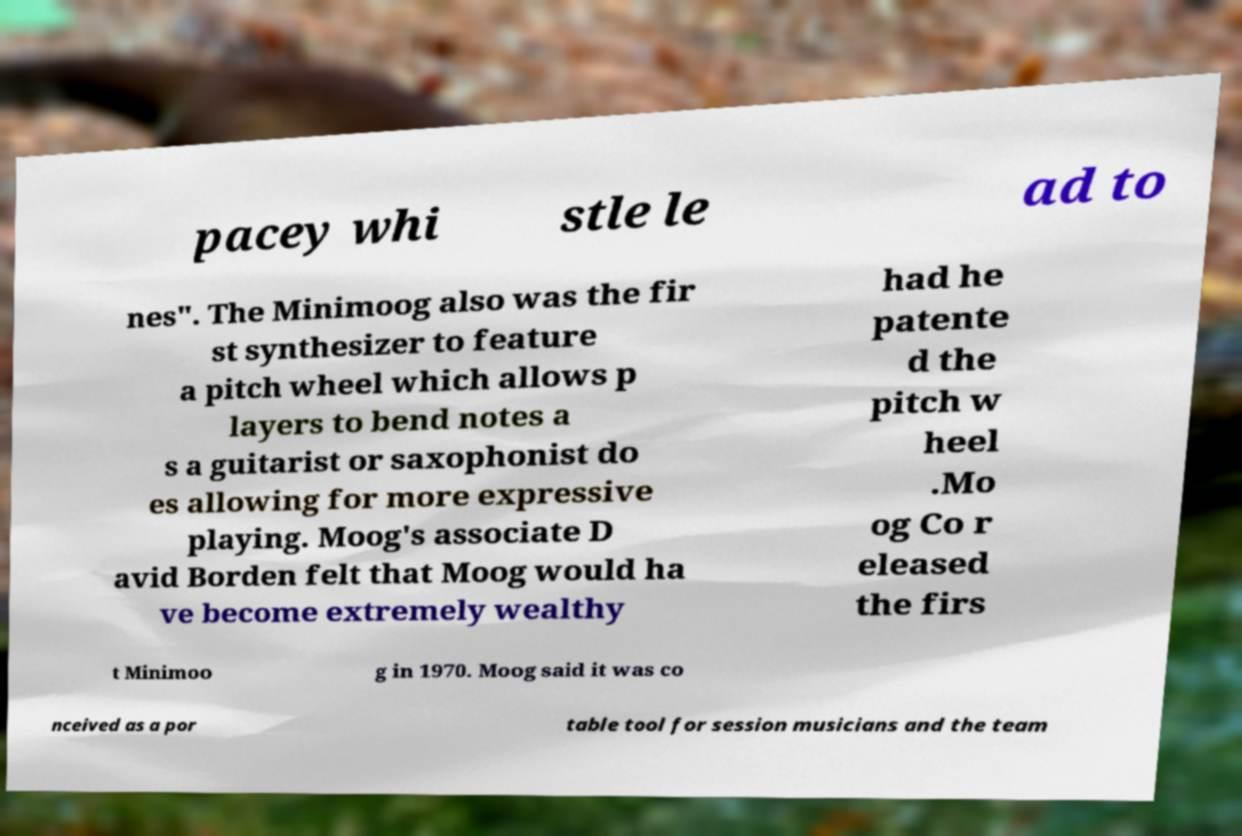Please identify and transcribe the text found in this image. pacey whi stle le ad to nes". The Minimoog also was the fir st synthesizer to feature a pitch wheel which allows p layers to bend notes a s a guitarist or saxophonist do es allowing for more expressive playing. Moog's associate D avid Borden felt that Moog would ha ve become extremely wealthy had he patente d the pitch w heel .Mo og Co r eleased the firs t Minimoo g in 1970. Moog said it was co nceived as a por table tool for session musicians and the team 